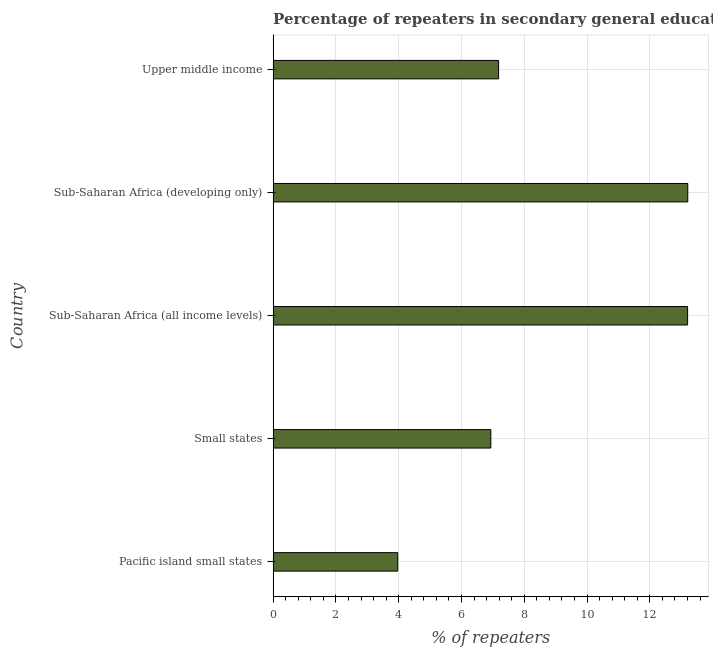Does the graph contain any zero values?
Your answer should be compact. No. What is the title of the graph?
Ensure brevity in your answer.  Percentage of repeaters in secondary general education of countries in the year 1989. What is the label or title of the X-axis?
Provide a short and direct response. % of repeaters. What is the label or title of the Y-axis?
Provide a succinct answer. Country. What is the percentage of repeaters in Sub-Saharan Africa (all income levels)?
Keep it short and to the point. 13.2. Across all countries, what is the maximum percentage of repeaters?
Ensure brevity in your answer.  13.21. Across all countries, what is the minimum percentage of repeaters?
Your response must be concise. 3.97. In which country was the percentage of repeaters maximum?
Your answer should be very brief. Sub-Saharan Africa (developing only). In which country was the percentage of repeaters minimum?
Make the answer very short. Pacific island small states. What is the sum of the percentage of repeaters?
Your answer should be compact. 44.5. What is the difference between the percentage of repeaters in Sub-Saharan Africa (all income levels) and Upper middle income?
Offer a terse response. 6.02. What is the average percentage of repeaters per country?
Provide a short and direct response. 8.9. What is the median percentage of repeaters?
Make the answer very short. 7.18. In how many countries, is the percentage of repeaters greater than 11.2 %?
Keep it short and to the point. 2. What is the ratio of the percentage of repeaters in Pacific island small states to that in Upper middle income?
Give a very brief answer. 0.55. Is the percentage of repeaters in Sub-Saharan Africa (all income levels) less than that in Sub-Saharan Africa (developing only)?
Give a very brief answer. Yes. Is the difference between the percentage of repeaters in Pacific island small states and Sub-Saharan Africa (all income levels) greater than the difference between any two countries?
Make the answer very short. No. What is the difference between the highest and the second highest percentage of repeaters?
Provide a succinct answer. 0.01. Is the sum of the percentage of repeaters in Pacific island small states and Small states greater than the maximum percentage of repeaters across all countries?
Provide a succinct answer. No. What is the difference between the highest and the lowest percentage of repeaters?
Give a very brief answer. 9.24. In how many countries, is the percentage of repeaters greater than the average percentage of repeaters taken over all countries?
Give a very brief answer. 2. Are all the bars in the graph horizontal?
Give a very brief answer. Yes. Are the values on the major ticks of X-axis written in scientific E-notation?
Your answer should be compact. No. What is the % of repeaters of Pacific island small states?
Your answer should be very brief. 3.97. What is the % of repeaters of Small states?
Make the answer very short. 6.94. What is the % of repeaters of Sub-Saharan Africa (all income levels)?
Your answer should be compact. 13.2. What is the % of repeaters in Sub-Saharan Africa (developing only)?
Ensure brevity in your answer.  13.21. What is the % of repeaters of Upper middle income?
Offer a very short reply. 7.18. What is the difference between the % of repeaters in Pacific island small states and Small states?
Offer a very short reply. -2.97. What is the difference between the % of repeaters in Pacific island small states and Sub-Saharan Africa (all income levels)?
Keep it short and to the point. -9.23. What is the difference between the % of repeaters in Pacific island small states and Sub-Saharan Africa (developing only)?
Your response must be concise. -9.24. What is the difference between the % of repeaters in Pacific island small states and Upper middle income?
Your answer should be very brief. -3.21. What is the difference between the % of repeaters in Small states and Sub-Saharan Africa (all income levels)?
Your answer should be very brief. -6.27. What is the difference between the % of repeaters in Small states and Sub-Saharan Africa (developing only)?
Keep it short and to the point. -6.27. What is the difference between the % of repeaters in Small states and Upper middle income?
Make the answer very short. -0.25. What is the difference between the % of repeaters in Sub-Saharan Africa (all income levels) and Sub-Saharan Africa (developing only)?
Provide a short and direct response. -0.01. What is the difference between the % of repeaters in Sub-Saharan Africa (all income levels) and Upper middle income?
Offer a very short reply. 6.02. What is the difference between the % of repeaters in Sub-Saharan Africa (developing only) and Upper middle income?
Offer a very short reply. 6.03. What is the ratio of the % of repeaters in Pacific island small states to that in Small states?
Ensure brevity in your answer.  0.57. What is the ratio of the % of repeaters in Pacific island small states to that in Sub-Saharan Africa (all income levels)?
Keep it short and to the point. 0.3. What is the ratio of the % of repeaters in Pacific island small states to that in Upper middle income?
Provide a succinct answer. 0.55. What is the ratio of the % of repeaters in Small states to that in Sub-Saharan Africa (all income levels)?
Offer a very short reply. 0.53. What is the ratio of the % of repeaters in Small states to that in Sub-Saharan Africa (developing only)?
Provide a short and direct response. 0.53. What is the ratio of the % of repeaters in Small states to that in Upper middle income?
Provide a short and direct response. 0.97. What is the ratio of the % of repeaters in Sub-Saharan Africa (all income levels) to that in Sub-Saharan Africa (developing only)?
Provide a short and direct response. 1. What is the ratio of the % of repeaters in Sub-Saharan Africa (all income levels) to that in Upper middle income?
Provide a short and direct response. 1.84. What is the ratio of the % of repeaters in Sub-Saharan Africa (developing only) to that in Upper middle income?
Provide a short and direct response. 1.84. 